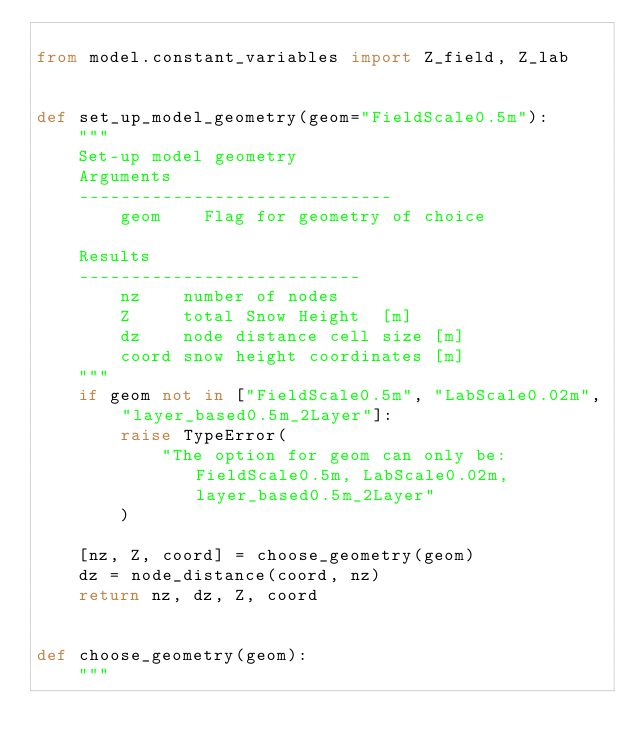<code> <loc_0><loc_0><loc_500><loc_500><_Python_>
from model.constant_variables import Z_field, Z_lab


def set_up_model_geometry(geom="FieldScale0.5m"):
    """
    Set-up model geometry 
    Arguments
    ------------------------------
        geom    Flag for geometry of choice

    Results
    ---------------------------
        nz    number of nodes 
        Z     total Snow Height  [m]
        dz    node distance cell size [m]
        coord snow height coordinates [m]
    """
    if geom not in ["FieldScale0.5m", "LabScale0.02m", "layer_based0.5m_2Layer"]:
        raise TypeError(
            "The option for geom can only be: FieldScale0.5m, LabScale0.02m, layer_based0.5m_2Layer"
        )

    [nz, Z, coord] = choose_geometry(geom)
    dz = node_distance(coord, nz)
    return nz, dz, Z, coord


def choose_geometry(geom):
    """</code> 